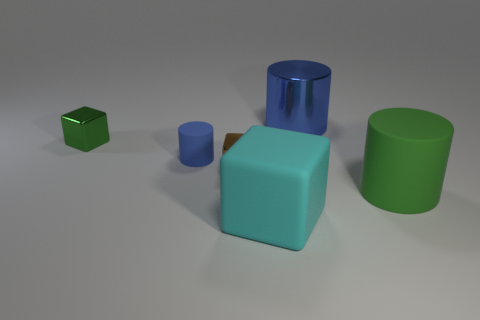Considering the positioning of the objects, what could this represent? The positioning of the objects might not depict a real-world scenario, but it could represent an abstract grouping or a stylized layout for showcasing shapes and colors. The arrangement may also serve educational purposes, such as a demonstration in a physics or geometry lesson about spatial relationships and varying sizes, as well as illustrating reflections and shadows under a certain light setup. 